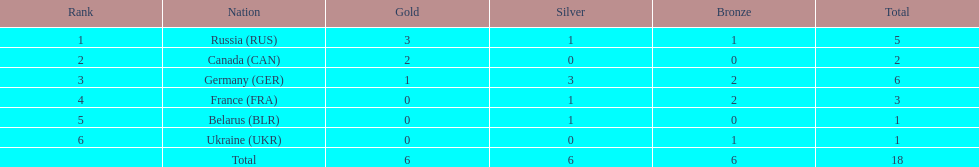In the 1994 winter olympics biathlon, which nation exclusively won gold medals? Canada (CAN). 